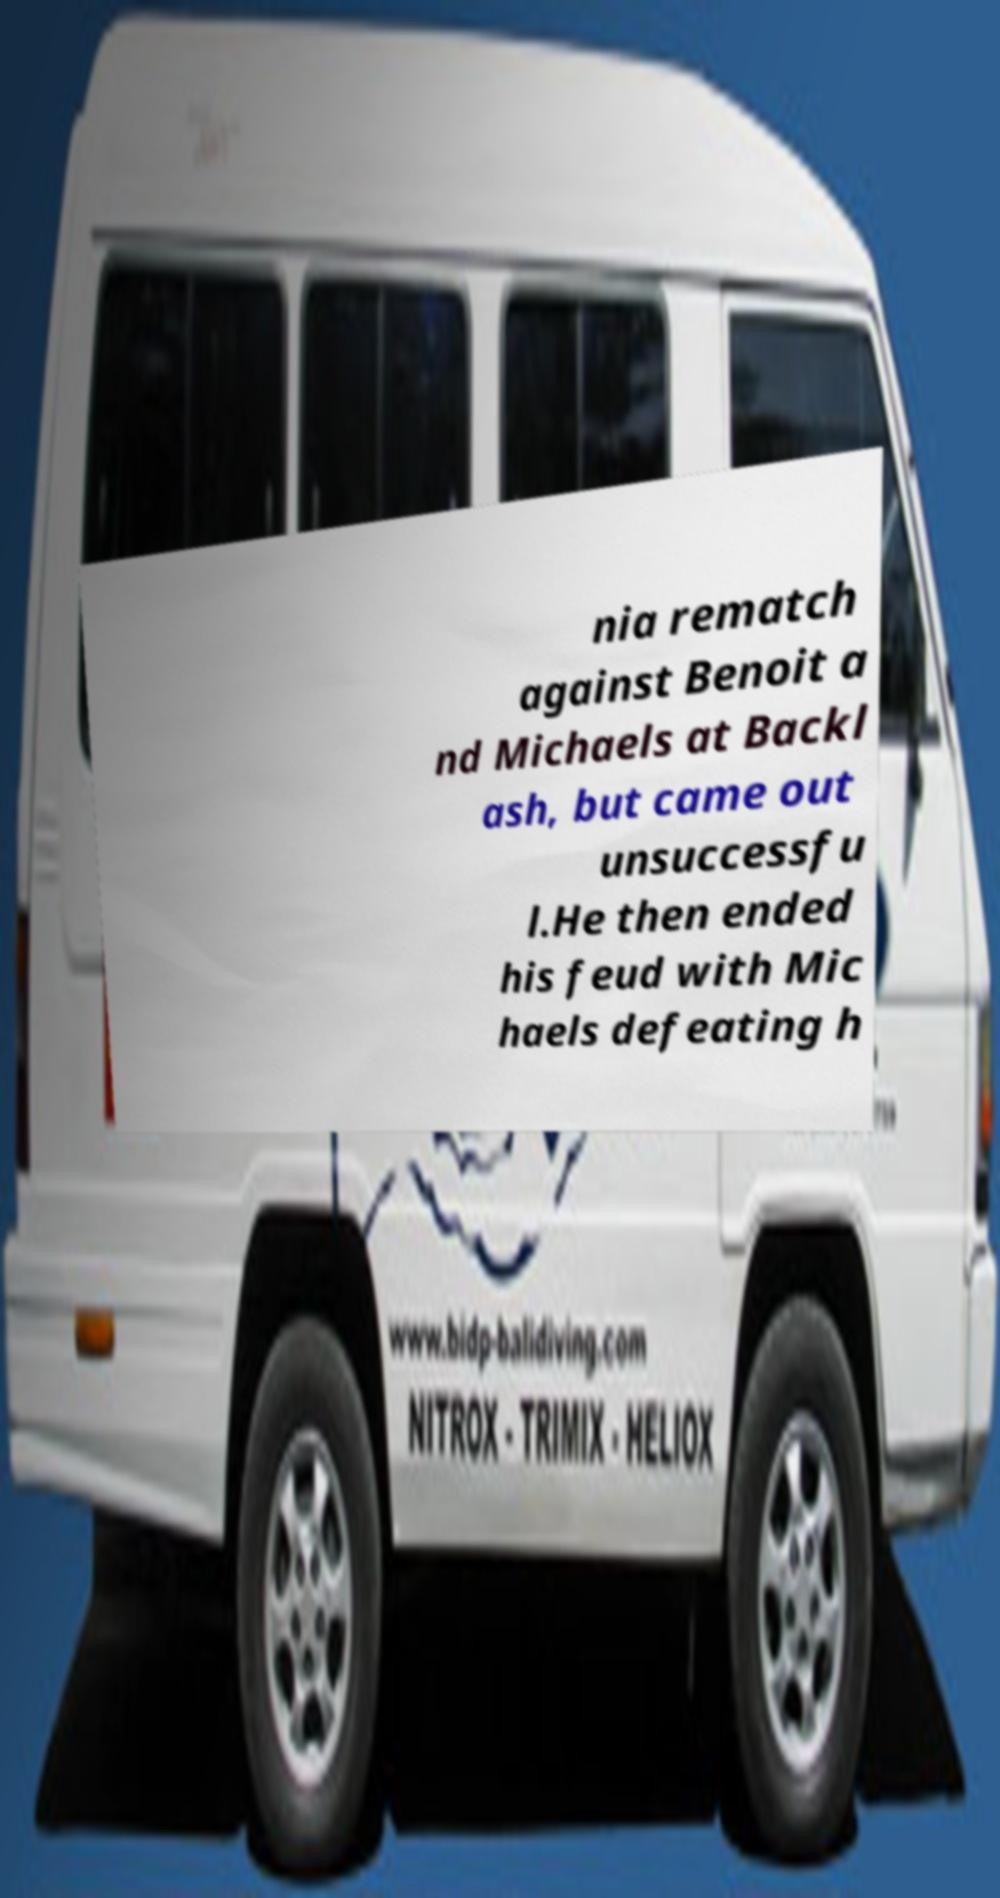Could you assist in decoding the text presented in this image and type it out clearly? nia rematch against Benoit a nd Michaels at Backl ash, but came out unsuccessfu l.He then ended his feud with Mic haels defeating h 